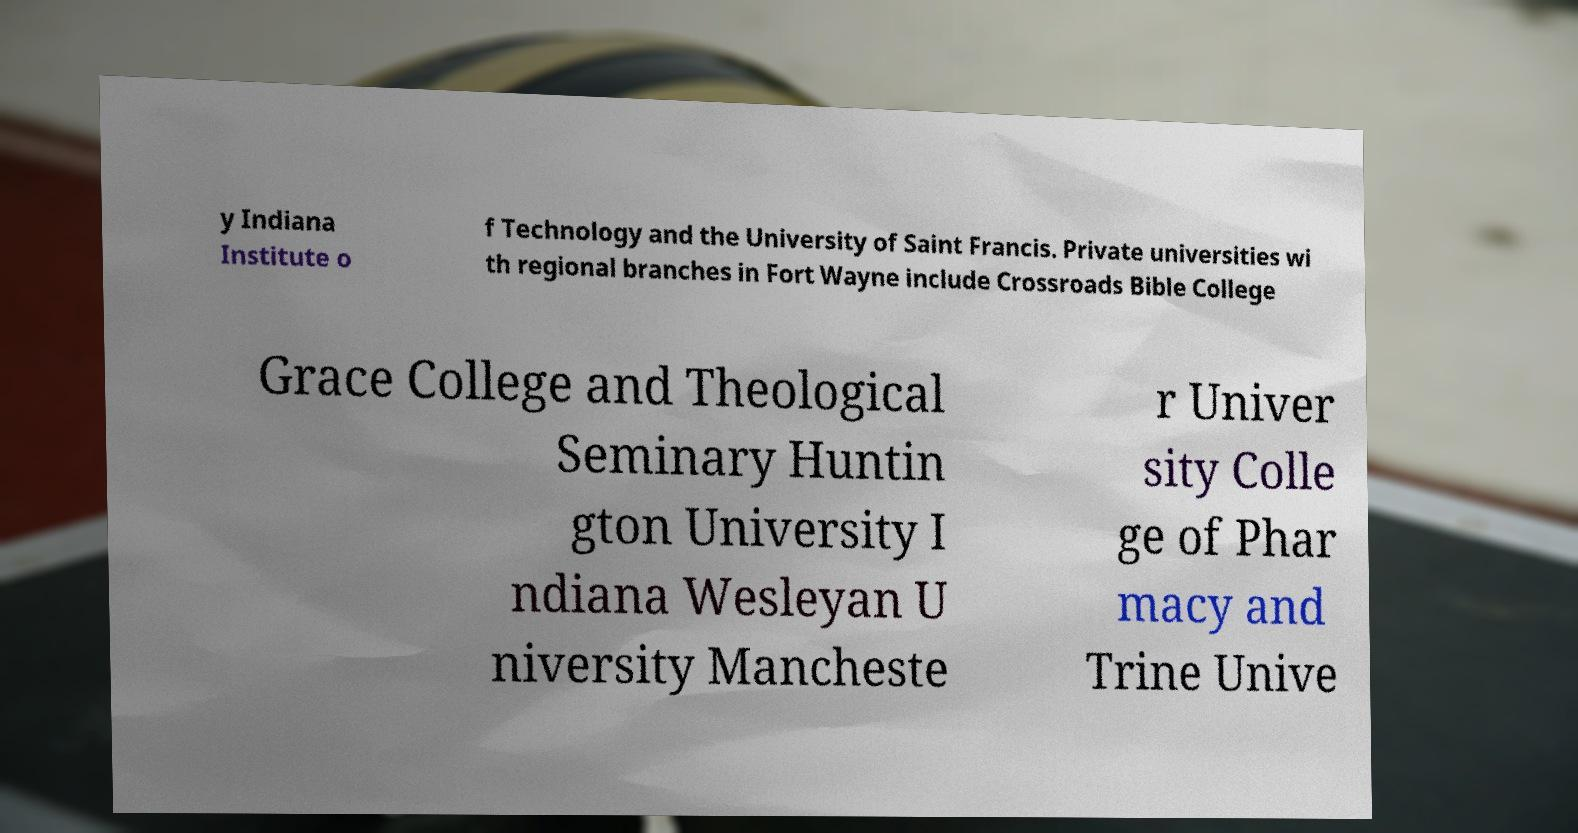There's text embedded in this image that I need extracted. Can you transcribe it verbatim? y Indiana Institute o f Technology and the University of Saint Francis. Private universities wi th regional branches in Fort Wayne include Crossroads Bible College Grace College and Theological Seminary Huntin gton University I ndiana Wesleyan U niversity Mancheste r Univer sity Colle ge of Phar macy and Trine Unive 